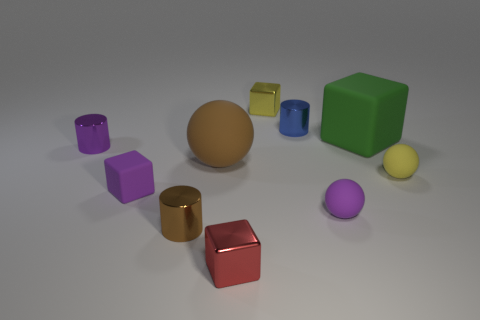Can you describe the spatial arrangement of the objects? Certainly! The objects are scattered across a flat surface with no discernible pattern. A large orange sphere is centrally located, with a variety of geometric shapes such as cylinders, cubes, and spheres in different colors and sizes surrounding it. 